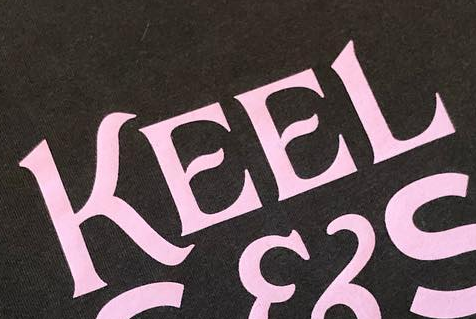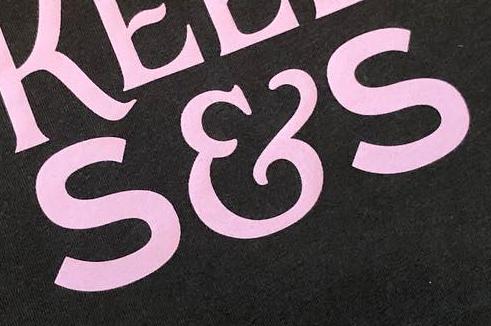Identify the words shown in these images in order, separated by a semicolon. KEEL; S&S 